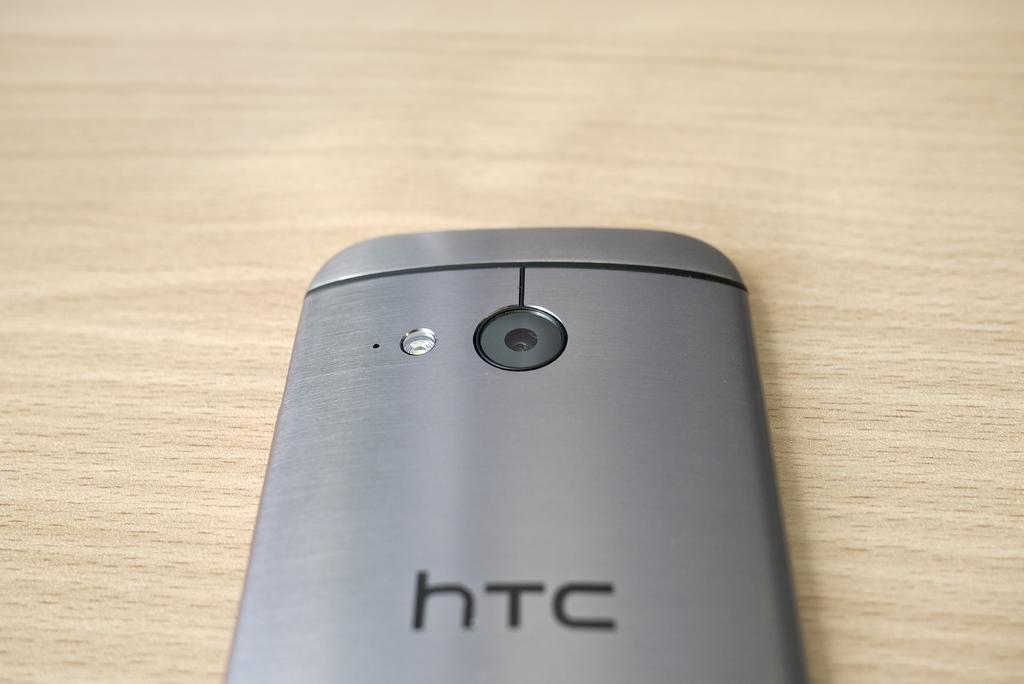<image>
Relay a brief, clear account of the picture shown. A silver HTC phone that is laying face down. 